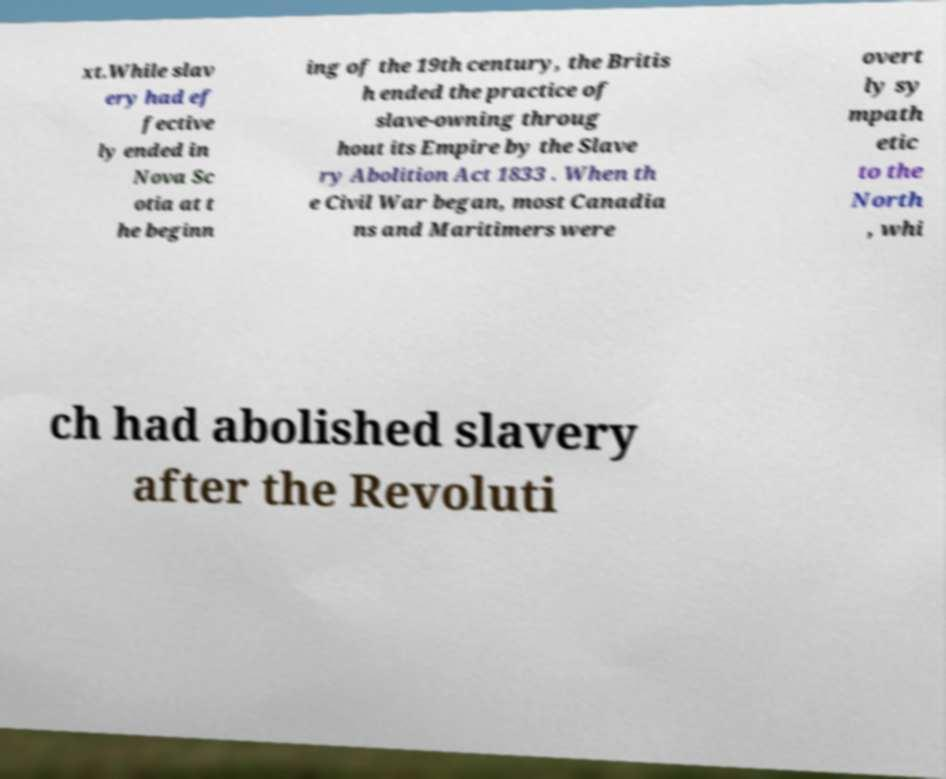For documentation purposes, I need the text within this image transcribed. Could you provide that? xt.While slav ery had ef fective ly ended in Nova Sc otia at t he beginn ing of the 19th century, the Britis h ended the practice of slave-owning throug hout its Empire by the Slave ry Abolition Act 1833 . When th e Civil War began, most Canadia ns and Maritimers were overt ly sy mpath etic to the North , whi ch had abolished slavery after the Revoluti 